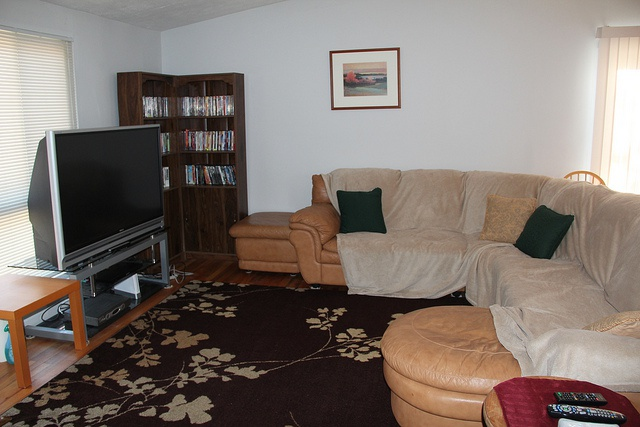Describe the objects in this image and their specific colors. I can see couch in gray, darkgray, and black tones, tv in gray, black, darkgray, and lightgray tones, book in gray, darkgray, maroon, and black tones, book in gray, black, darkgray, and maroon tones, and remote in gray, black, darkgray, and navy tones in this image. 